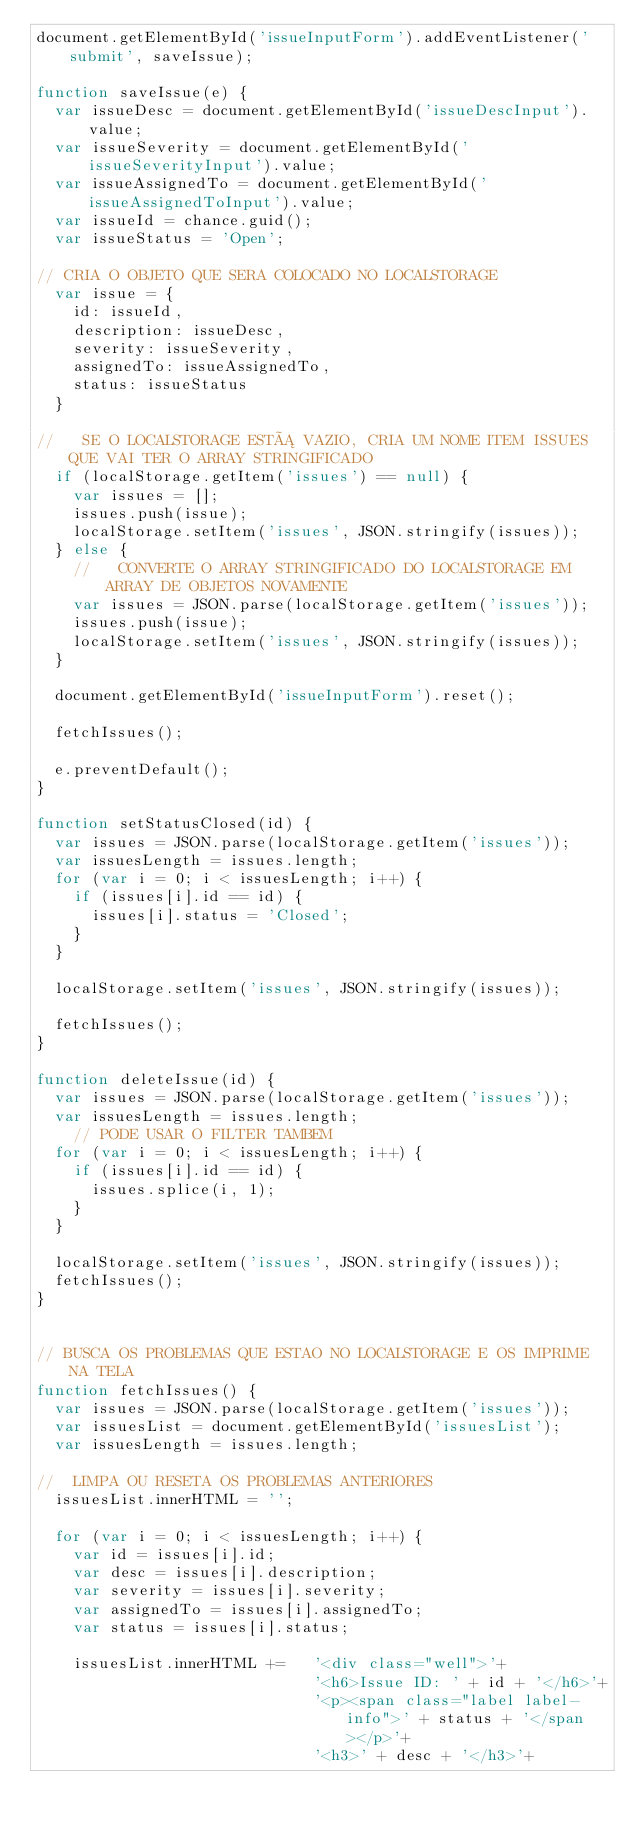<code> <loc_0><loc_0><loc_500><loc_500><_JavaScript_>document.getElementById('issueInputForm').addEventListener('submit', saveIssue);

function saveIssue(e) {
  var issueDesc = document.getElementById('issueDescInput').value;
  var issueSeverity = document.getElementById('issueSeverityInput').value;
  var issueAssignedTo = document.getElementById('issueAssignedToInput').value;
  var issueId = chance.guid();
  var issueStatus = 'Open';
  
// CRIA O OBJETO QUE SERA COLOCADO NO LOCALSTORAGE
  var issue = {
    id: issueId,
    description: issueDesc,
    severity: issueSeverity,
    assignedTo: issueAssignedTo,
    status: issueStatus
  }

//   SE O LOCALSTORAGE ESTÁ VAZIO, CRIA UM NOME ITEM ISSUES QUE VAI TER O ARRAY STRINGIFICADO
  if (localStorage.getItem('issues') == null) {
    var issues = [];
    issues.push(issue);
    localStorage.setItem('issues', JSON.stringify(issues));
  } else {
    //   CONVERTE O ARRAY STRINGIFICADO DO LOCALSTORAGE EM ARRAY DE OBJETOS NOVAMENTE
    var issues = JSON.parse(localStorage.getItem('issues'));
    issues.push(issue);
    localStorage.setItem('issues', JSON.stringify(issues));
  }

  document.getElementById('issueInputForm').reset();

  fetchIssues();

  e.preventDefault();
}

function setStatusClosed(id) {
  var issues = JSON.parse(localStorage.getItem('issues'));
  var issuesLength = issues.length;
  for (var i = 0; i < issuesLength; i++) {
    if (issues[i].id == id) {
      issues[i].status = 'Closed';
    }
  }

  localStorage.setItem('issues', JSON.stringify(issues));

  fetchIssues();
}

function deleteIssue(id) {
  var issues = JSON.parse(localStorage.getItem('issues'));
  var issuesLength = issues.length;
    // PODE USAR O FILTER TAMBEM
  for (var i = 0; i < issuesLength; i++) {
    if (issues[i].id == id) {
      issues.splice(i, 1);
    }
  }

  localStorage.setItem('issues', JSON.stringify(issues));
  fetchIssues();
}


// BUSCA OS PROBLEMAS QUE ESTAO NO LOCALSTORAGE E OS IMPRIME NA TELA
function fetchIssues() {
  var issues = JSON.parse(localStorage.getItem('issues'));
  var issuesList = document.getElementById('issuesList');
  var issuesLength = issues.length;

//  LIMPA OU RESETA OS PROBLEMAS ANTERIORES
  issuesList.innerHTML = '';

  for (var i = 0; i < issuesLength; i++) {
    var id = issues[i].id;
    var desc = issues[i].description;
    var severity = issues[i].severity;
    var assignedTo = issues[i].assignedTo;
    var status = issues[i].status;

    issuesList.innerHTML +=   '<div class="well">'+
                              '<h6>Issue ID: ' + id + '</h6>'+
                              '<p><span class="label label-info">' + status + '</span></p>'+
                              '<h3>' + desc + '</h3>'+</code> 